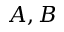<formula> <loc_0><loc_0><loc_500><loc_500>A , B</formula> 